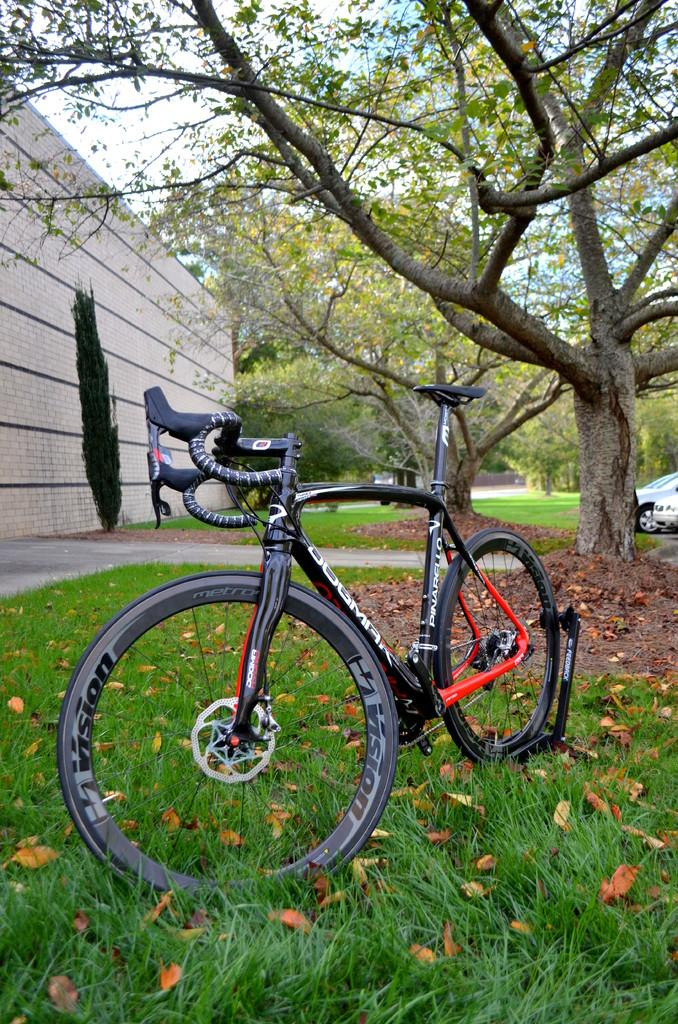What type of surface is visible in the image? There is a grass surface in the image. What is parked on the grass surface? A bicycle is parked on the grass surface. What type of vegetation is visible in the image? There are trees visible in the image. What architectural feature can be seen in the image? There is a part of a wall in the image. Can you see any jellyfish swimming in the image? There are no jellyfish present in the image; it features a grass surface, a bicycle, trees, and a part of a wall. 